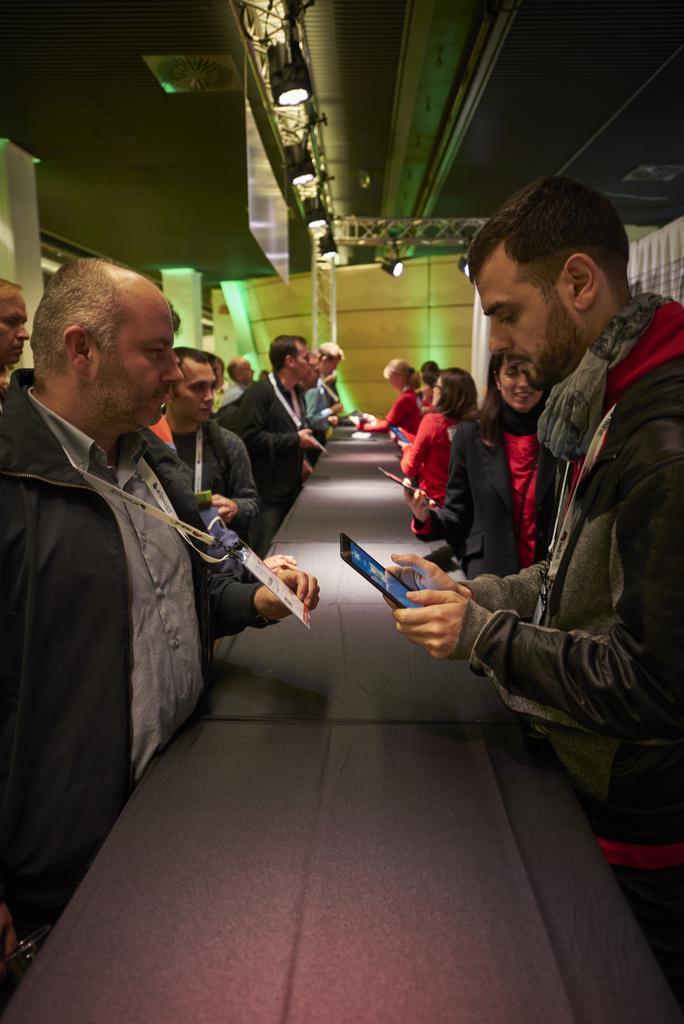Please provide a concise description of this image. In this picture I can see many people who are standing near to the table and some peoples are holding tablets. At the top I can see the focus lights which are placed on the roof. On the left I can see some clothes on the window. 